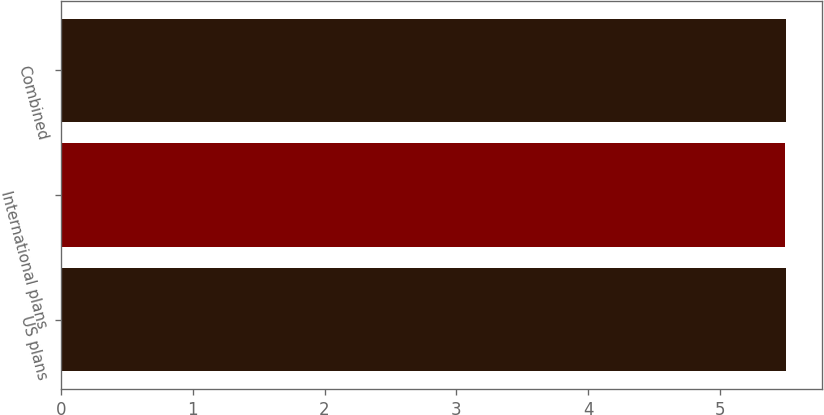<chart> <loc_0><loc_0><loc_500><loc_500><bar_chart><fcel>US plans<fcel>International plans<fcel>Combined<nl><fcel>5.5<fcel>5.49<fcel>5.5<nl></chart> 